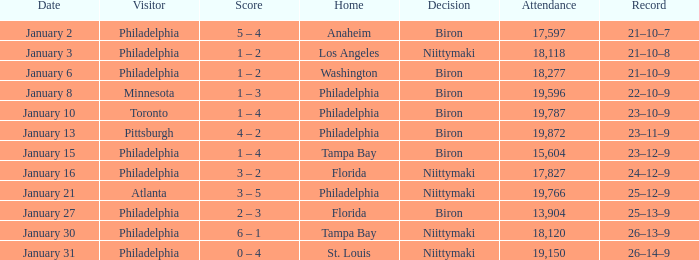What is the decision of the game on January 13? Biron. Can you give me this table as a dict? {'header': ['Date', 'Visitor', 'Score', 'Home', 'Decision', 'Attendance', 'Record'], 'rows': [['January 2', 'Philadelphia', '5 – 4', 'Anaheim', 'Biron', '17,597', '21–10–7'], ['January 3', 'Philadelphia', '1 – 2', 'Los Angeles', 'Niittymaki', '18,118', '21–10–8'], ['January 6', 'Philadelphia', '1 – 2', 'Washington', 'Biron', '18,277', '21–10–9'], ['January 8', 'Minnesota', '1 – 3', 'Philadelphia', 'Biron', '19,596', '22–10–9'], ['January 10', 'Toronto', '1 – 4', 'Philadelphia', 'Biron', '19,787', '23–10–9'], ['January 13', 'Pittsburgh', '4 – 2', 'Philadelphia', 'Biron', '19,872', '23–11–9'], ['January 15', 'Philadelphia', '1 – 4', 'Tampa Bay', 'Biron', '15,604', '23–12–9'], ['January 16', 'Philadelphia', '3 – 2', 'Florida', 'Niittymaki', '17,827', '24–12–9'], ['January 21', 'Atlanta', '3 – 5', 'Philadelphia', 'Niittymaki', '19,766', '25–12–9'], ['January 27', 'Philadelphia', '2 – 3', 'Florida', 'Biron', '13,904', '25–13–9'], ['January 30', 'Philadelphia', '6 – 1', 'Tampa Bay', 'Niittymaki', '18,120', '26–13–9'], ['January 31', 'Philadelphia', '0 – 4', 'St. Louis', 'Niittymaki', '19,150', '26–14–9']]} 